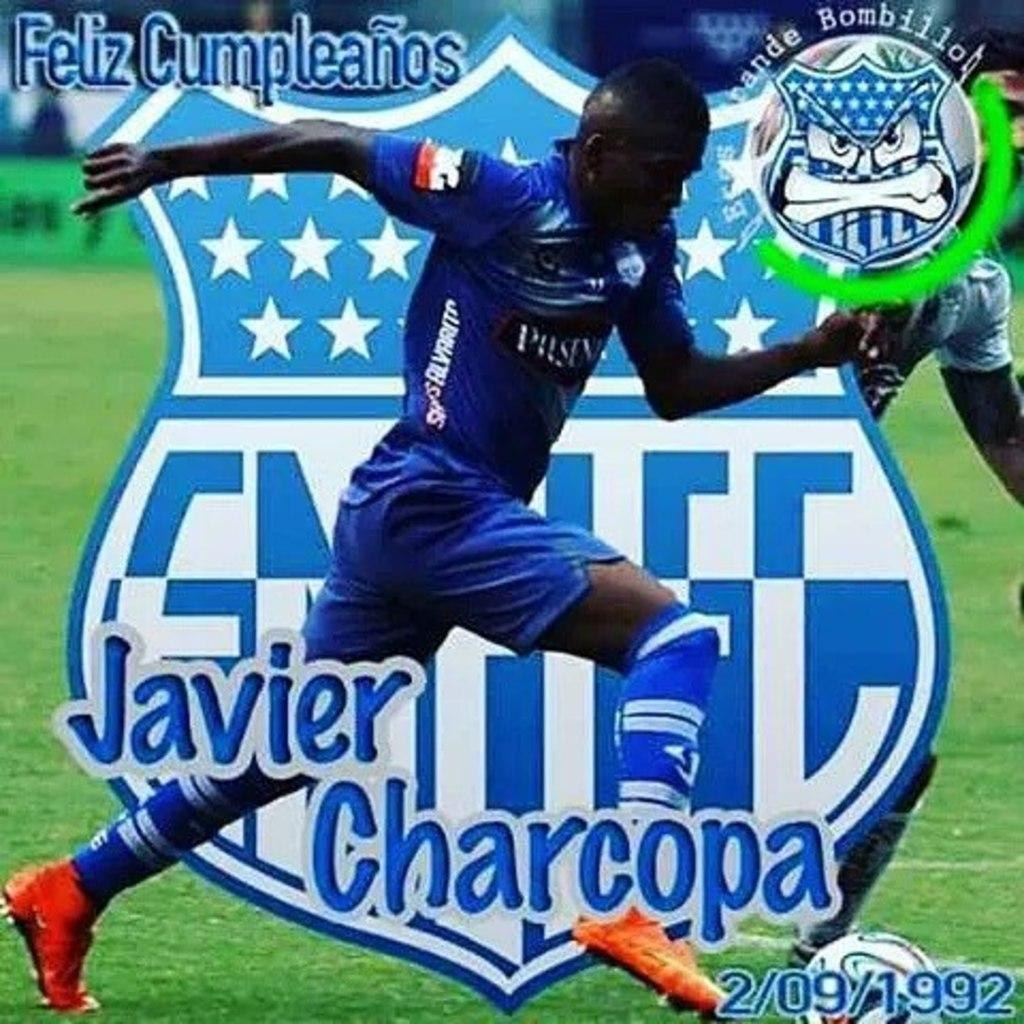<image>
Describe the image concisely. The soccer player on the advertisement is named Javier Charcopa. 